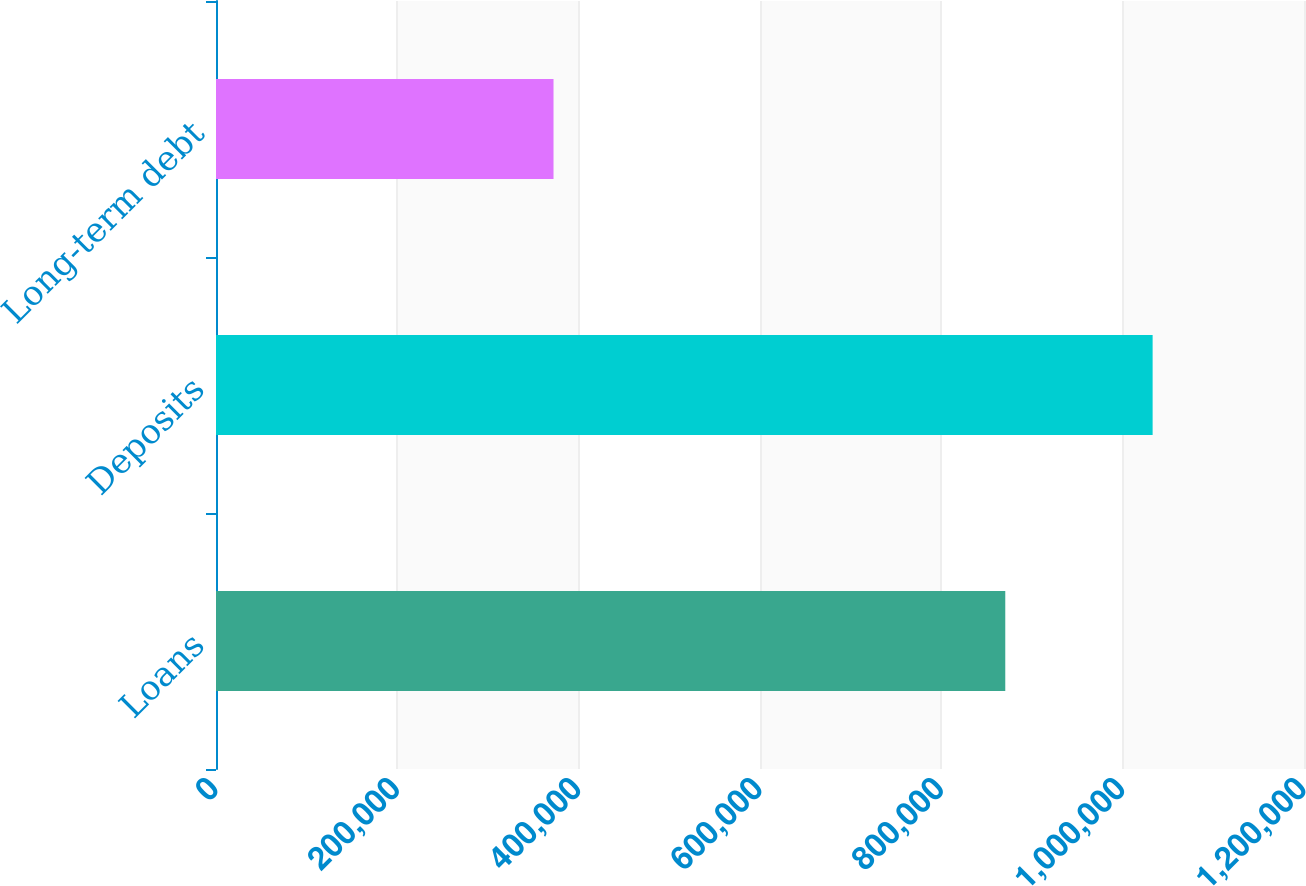Convert chart to OTSL. <chart><loc_0><loc_0><loc_500><loc_500><bar_chart><fcel>Loans<fcel>Deposits<fcel>Long-term debt<nl><fcel>870520<fcel>1.03304e+06<fcel>372265<nl></chart> 